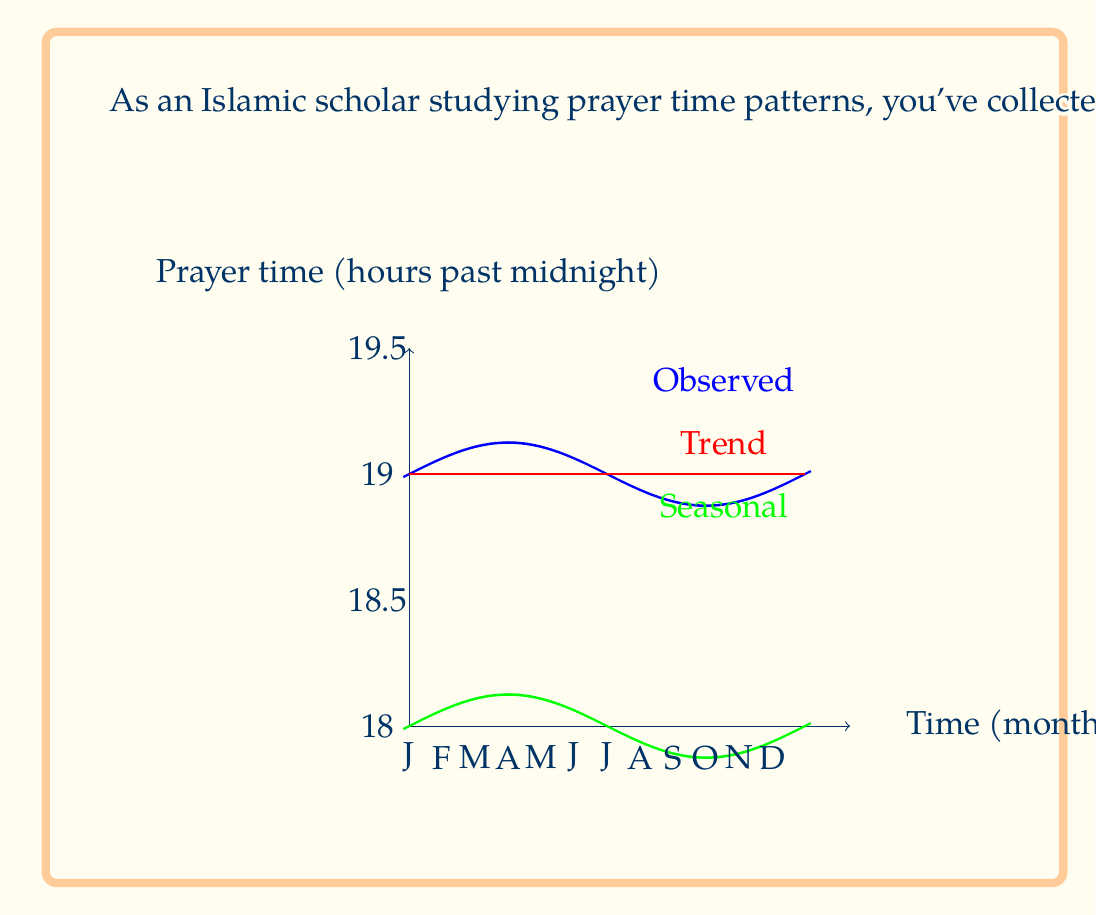What is the answer to this math problem? To solve this problem, we need to use the additive seasonal decomposition model for time series analysis. This model assumes that a time series can be decomposed into three components: trend, seasonal, and random (residual).

The additive model is represented as:

$$Y_t = T_t + S_t + R_t$$

Where:
$Y_t$ is the observed value
$T_t$ is the trend component
$S_t$ is the seasonal component
$R_t$ is the random (residual) component

Given:
1. Observed Maghrib prayer time ($Y_t$) = 18:45 = 18.75 hours
2. Trend component ($T_t$) = 18:30 = 18.5 hours
3. Seasonal component ($S_t$) = 0.25 hours

To find the random component ($R_t$), we rearrange the equation:

$$R_t = Y_t - T_t - S_t$$

Now, let's substitute the values:

$$R_t = 18.75 - 18.5 - 0.25$$

$$R_t = 0$$

Therefore, the random (residual) component for this day is 0 hours.
Answer: 0 hours 